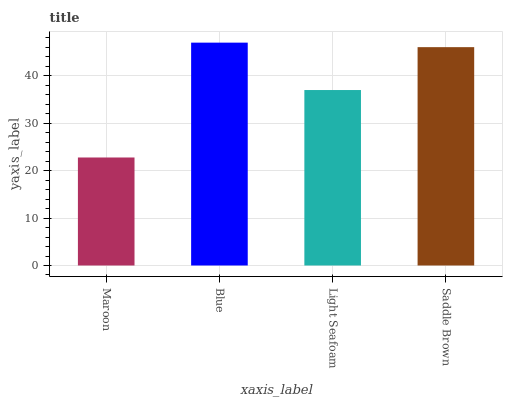Is Maroon the minimum?
Answer yes or no. Yes. Is Blue the maximum?
Answer yes or no. Yes. Is Light Seafoam the minimum?
Answer yes or no. No. Is Light Seafoam the maximum?
Answer yes or no. No. Is Blue greater than Light Seafoam?
Answer yes or no. Yes. Is Light Seafoam less than Blue?
Answer yes or no. Yes. Is Light Seafoam greater than Blue?
Answer yes or no. No. Is Blue less than Light Seafoam?
Answer yes or no. No. Is Saddle Brown the high median?
Answer yes or no. Yes. Is Light Seafoam the low median?
Answer yes or no. Yes. Is Light Seafoam the high median?
Answer yes or no. No. Is Maroon the low median?
Answer yes or no. No. 